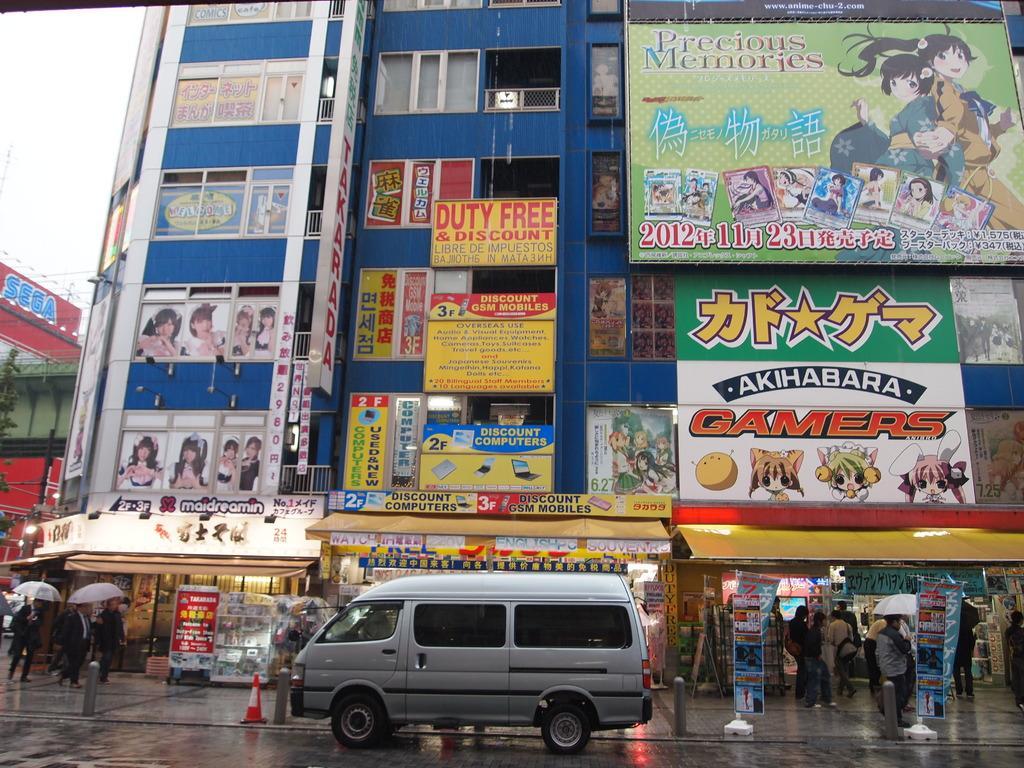Can you describe this image briefly? As we can see in the image there are buildings, banners, current pole, sky, few people here and there, van, traffic cone and umbrellas. 